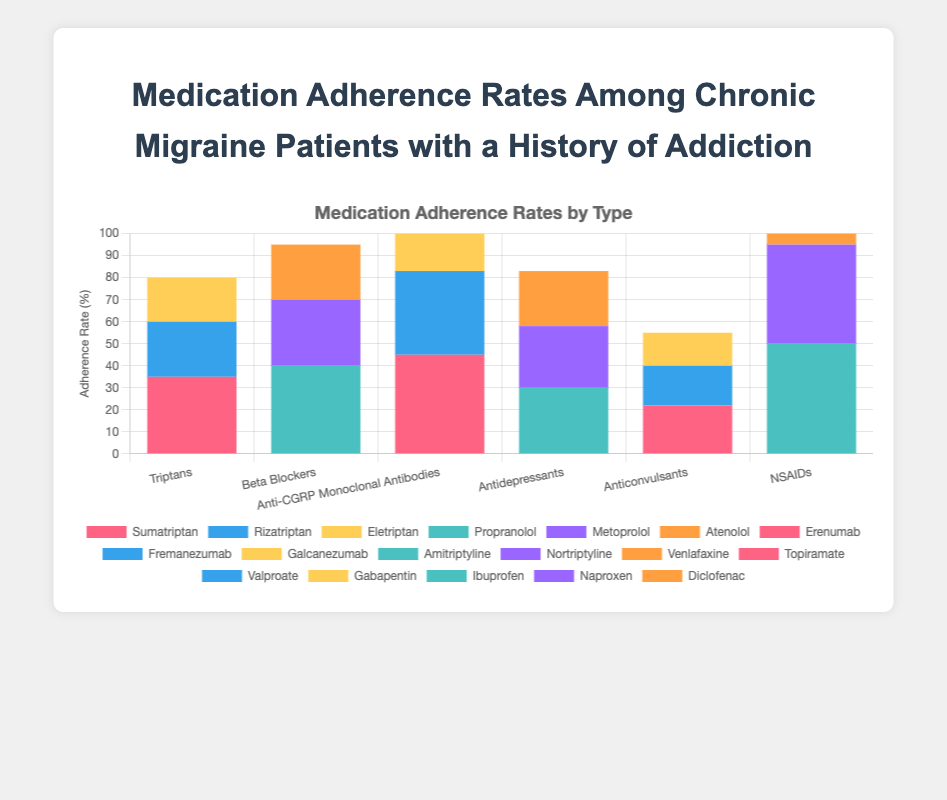What is the adherence rate for Ibuprofen? Look at the bar representing NSAIDs and identify the segment colored for Ibuprofen, then read its height value.
Answer: 50 Which medication type has the highest adherence rate overall? Sum the adherence rates for each medication type: Triptans (35+25+20=80), Beta Blockers (40+30+25=95), Anti-CGRP Monoclonal Antibodies (45+38+40=123), Antidepressants (30+28+25=83), Anticonvulsants (22+18+15=55), NSAIDs (50+45+42=137). Compare these sums to find the highest one.
Answer: NSAIDs Between Erenumab and Sumatriptan, which has a higher adherence rate? Look at the heights of the bars for Erenumab (Anti-CGRP Monoclonal Antibodies) and Sumatriptan (Triptans) to compare their values.
Answer: Erenumab What is the total adherence rate for all types of Beta Blockers? Add the adherence rates for Propranolol, Metoprolol, and Atenolol (40+30+25).
Answer: 95 What is the average adherence rate for Anticonvulsants? Sum the adherence rates for Topiramate, Valproate, and Gabapentin (22+18+15) and then divide by the number of medications (3).
Answer: 18.33 Which medication has the lowest adherence rate among all types? Identify the bar segment with the smallest height across all medication types and read its value.
Answer: Gabapentin Which segment is larger, Naproxen or Galcanezumab? Compare the heights of the bar segments for Naproxen (NSAIDs) and Galcanezumab (Anti-CGRP Monoclonal Antibodies).
Answer: Naproxen What is the difference in adherence rates between Propranolol and Amitriptyline? Subtract the adherence rate of Amitriptyline from that of Propranolol (40-30).
Answer: 10 How many types of medication show an adherence rate for Venlafaxine? Identify the medication type containing Venlafaxine (Antidepressants) and check if other types include it.
Answer: 1 What color represents the adherence rate for Diclofenac? Refer to the legend or directly observe the color of the bar segment associated with Diclofenac (NSAIDs).
Answer: Various shades of blue/red, depending on the specific color used in the plot's rendering 